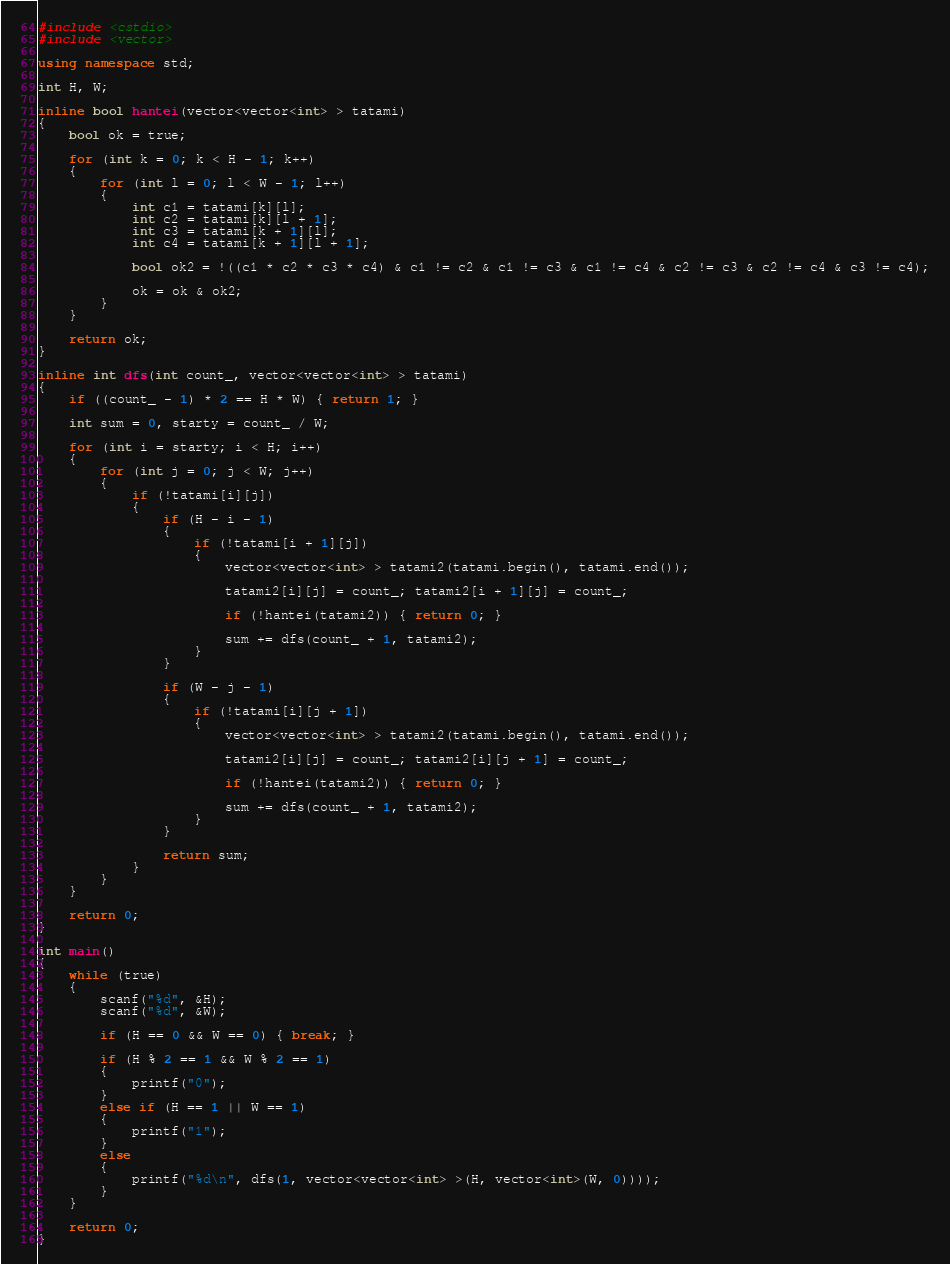<code> <loc_0><loc_0><loc_500><loc_500><_C++_>#include <cstdio>
#include <vector>

using namespace std;

int H, W;

inline bool hantei(vector<vector<int> > tatami)
{
	bool ok = true;

	for (int k = 0; k < H - 1; k++)
	{
		for (int l = 0; l < W - 1; l++)
		{
			int c1 = tatami[k][l];
			int c2 = tatami[k][l + 1];
			int c3 = tatami[k + 1][l];
			int c4 = tatami[k + 1][l + 1];

			bool ok2 = !((c1 * c2 * c3 * c4) & c1 != c2 & c1 != c3 & c1 != c4 & c2 != c3 & c2 != c4 & c3 != c4);

			ok = ok & ok2;
		}
	}

	return ok;
}

inline int dfs(int count_, vector<vector<int> > tatami)
{
	if ((count_ - 1) * 2 == H * W) { return 1; }

	int sum = 0, starty = count_ / W;

	for (int i = starty; i < H; i++)
	{
		for (int j = 0; j < W; j++)
		{
			if (!tatami[i][j])
			{
				if (H - i - 1)
				{
					if (!tatami[i + 1][j])
					{
						vector<vector<int> > tatami2(tatami.begin(), tatami.end());

						tatami2[i][j] = count_; tatami2[i + 1][j] = count_;

						if (!hantei(tatami2)) { return 0; }

						sum += dfs(count_ + 1, tatami2);
					}
				}

				if (W - j - 1)
				{
					if (!tatami[i][j + 1])
					{
						vector<vector<int> > tatami2(tatami.begin(), tatami.end());

						tatami2[i][j] = count_; tatami2[i][j + 1] = count_;

						if (!hantei(tatami2)) { return 0; }

						sum += dfs(count_ + 1, tatami2);
					}
				}

				return sum;
			}
		}
	}

	return 0;
}

int main()
{
	while (true)
	{
		scanf("%d", &H);
		scanf("%d", &W);

		if (H == 0 && W == 0) { break; }

		if (H % 2 == 1 && W % 2 == 1)
		{
			printf("0");
		}
		else if (H == 1 || W == 1)
		{
			printf("1");
		}
		else
		{
			printf("%d\n", dfs(1, vector<vector<int> >(H, vector<int>(W, 0))));
		}
	}

	return 0;
}</code> 